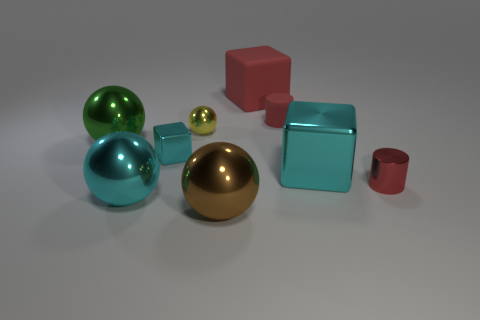Add 1 cyan shiny cylinders. How many objects exist? 10 Subtract all cylinders. How many objects are left? 7 Subtract 0 blue balls. How many objects are left? 9 Subtract all red things. Subtract all big blue shiny objects. How many objects are left? 6 Add 3 green balls. How many green balls are left? 4 Add 5 tiny cyan blocks. How many tiny cyan blocks exist? 6 